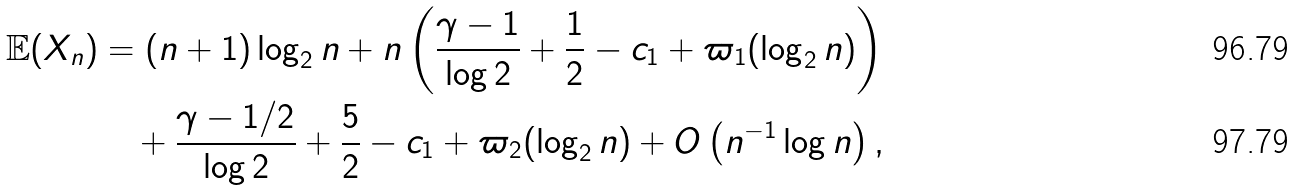Convert formula to latex. <formula><loc_0><loc_0><loc_500><loc_500>\mathbb { E } ( X _ { n } ) & = ( n + 1 ) \log _ { 2 } n + n \left ( \frac { \gamma - 1 } { \log 2 } + \frac { 1 } { 2 } - c _ { 1 } + \varpi _ { 1 } ( \log _ { 2 } n ) \right ) \\ & \quad + \frac { \gamma - 1 / 2 } { \log 2 } + \frac { 5 } { 2 } - c _ { 1 } + \varpi _ { 2 } ( \log _ { 2 } n ) + O \left ( n ^ { - 1 } \log n \right ) ,</formula> 